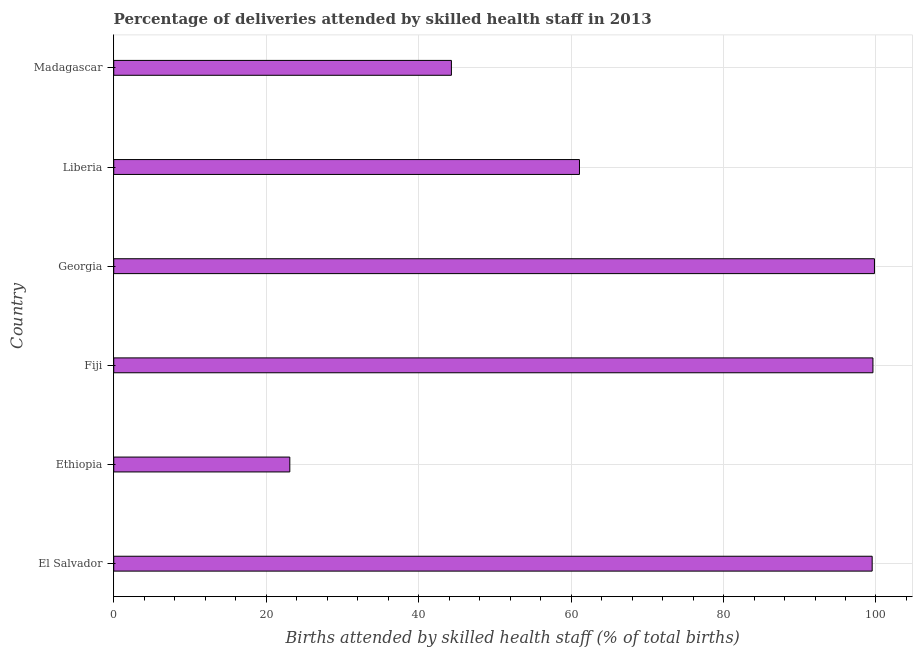Does the graph contain any zero values?
Offer a very short reply. No. Does the graph contain grids?
Your answer should be very brief. Yes. What is the title of the graph?
Offer a terse response. Percentage of deliveries attended by skilled health staff in 2013. What is the label or title of the X-axis?
Give a very brief answer. Births attended by skilled health staff (% of total births). What is the label or title of the Y-axis?
Make the answer very short. Country. What is the number of births attended by skilled health staff in Georgia?
Provide a succinct answer. 99.8. Across all countries, what is the maximum number of births attended by skilled health staff?
Keep it short and to the point. 99.8. Across all countries, what is the minimum number of births attended by skilled health staff?
Your answer should be very brief. 23.1. In which country was the number of births attended by skilled health staff maximum?
Give a very brief answer. Georgia. In which country was the number of births attended by skilled health staff minimum?
Provide a short and direct response. Ethiopia. What is the sum of the number of births attended by skilled health staff?
Provide a succinct answer. 427.4. What is the difference between the number of births attended by skilled health staff in Fiji and Madagascar?
Provide a succinct answer. 55.3. What is the average number of births attended by skilled health staff per country?
Give a very brief answer. 71.23. What is the median number of births attended by skilled health staff?
Keep it short and to the point. 80.3. What is the ratio of the number of births attended by skilled health staff in Liberia to that in Madagascar?
Your response must be concise. 1.38. Is the sum of the number of births attended by skilled health staff in El Salvador and Fiji greater than the maximum number of births attended by skilled health staff across all countries?
Ensure brevity in your answer.  Yes. What is the difference between the highest and the lowest number of births attended by skilled health staff?
Your answer should be very brief. 76.7. In how many countries, is the number of births attended by skilled health staff greater than the average number of births attended by skilled health staff taken over all countries?
Offer a terse response. 3. Are all the bars in the graph horizontal?
Your answer should be very brief. Yes. What is the difference between two consecutive major ticks on the X-axis?
Give a very brief answer. 20. Are the values on the major ticks of X-axis written in scientific E-notation?
Your answer should be very brief. No. What is the Births attended by skilled health staff (% of total births) of El Salvador?
Keep it short and to the point. 99.5. What is the Births attended by skilled health staff (% of total births) in Ethiopia?
Give a very brief answer. 23.1. What is the Births attended by skilled health staff (% of total births) in Fiji?
Provide a succinct answer. 99.6. What is the Births attended by skilled health staff (% of total births) of Georgia?
Provide a short and direct response. 99.8. What is the Births attended by skilled health staff (% of total births) of Liberia?
Provide a short and direct response. 61.1. What is the Births attended by skilled health staff (% of total births) in Madagascar?
Provide a succinct answer. 44.3. What is the difference between the Births attended by skilled health staff (% of total births) in El Salvador and Ethiopia?
Your answer should be very brief. 76.4. What is the difference between the Births attended by skilled health staff (% of total births) in El Salvador and Fiji?
Provide a succinct answer. -0.1. What is the difference between the Births attended by skilled health staff (% of total births) in El Salvador and Georgia?
Offer a terse response. -0.3. What is the difference between the Births attended by skilled health staff (% of total births) in El Salvador and Liberia?
Your answer should be compact. 38.4. What is the difference between the Births attended by skilled health staff (% of total births) in El Salvador and Madagascar?
Offer a terse response. 55.2. What is the difference between the Births attended by skilled health staff (% of total births) in Ethiopia and Fiji?
Provide a short and direct response. -76.5. What is the difference between the Births attended by skilled health staff (% of total births) in Ethiopia and Georgia?
Your answer should be very brief. -76.7. What is the difference between the Births attended by skilled health staff (% of total births) in Ethiopia and Liberia?
Provide a succinct answer. -38. What is the difference between the Births attended by skilled health staff (% of total births) in Ethiopia and Madagascar?
Your answer should be very brief. -21.2. What is the difference between the Births attended by skilled health staff (% of total births) in Fiji and Georgia?
Offer a very short reply. -0.2. What is the difference between the Births attended by skilled health staff (% of total births) in Fiji and Liberia?
Make the answer very short. 38.5. What is the difference between the Births attended by skilled health staff (% of total births) in Fiji and Madagascar?
Make the answer very short. 55.3. What is the difference between the Births attended by skilled health staff (% of total births) in Georgia and Liberia?
Ensure brevity in your answer.  38.7. What is the difference between the Births attended by skilled health staff (% of total births) in Georgia and Madagascar?
Make the answer very short. 55.5. What is the difference between the Births attended by skilled health staff (% of total births) in Liberia and Madagascar?
Your response must be concise. 16.8. What is the ratio of the Births attended by skilled health staff (% of total births) in El Salvador to that in Ethiopia?
Ensure brevity in your answer.  4.31. What is the ratio of the Births attended by skilled health staff (% of total births) in El Salvador to that in Fiji?
Your answer should be compact. 1. What is the ratio of the Births attended by skilled health staff (% of total births) in El Salvador to that in Georgia?
Your answer should be very brief. 1. What is the ratio of the Births attended by skilled health staff (% of total births) in El Salvador to that in Liberia?
Provide a succinct answer. 1.63. What is the ratio of the Births attended by skilled health staff (% of total births) in El Salvador to that in Madagascar?
Provide a short and direct response. 2.25. What is the ratio of the Births attended by skilled health staff (% of total births) in Ethiopia to that in Fiji?
Give a very brief answer. 0.23. What is the ratio of the Births attended by skilled health staff (% of total births) in Ethiopia to that in Georgia?
Your answer should be very brief. 0.23. What is the ratio of the Births attended by skilled health staff (% of total births) in Ethiopia to that in Liberia?
Give a very brief answer. 0.38. What is the ratio of the Births attended by skilled health staff (% of total births) in Ethiopia to that in Madagascar?
Provide a short and direct response. 0.52. What is the ratio of the Births attended by skilled health staff (% of total births) in Fiji to that in Georgia?
Offer a terse response. 1. What is the ratio of the Births attended by skilled health staff (% of total births) in Fiji to that in Liberia?
Offer a terse response. 1.63. What is the ratio of the Births attended by skilled health staff (% of total births) in Fiji to that in Madagascar?
Keep it short and to the point. 2.25. What is the ratio of the Births attended by skilled health staff (% of total births) in Georgia to that in Liberia?
Give a very brief answer. 1.63. What is the ratio of the Births attended by skilled health staff (% of total births) in Georgia to that in Madagascar?
Offer a very short reply. 2.25. What is the ratio of the Births attended by skilled health staff (% of total births) in Liberia to that in Madagascar?
Provide a succinct answer. 1.38. 